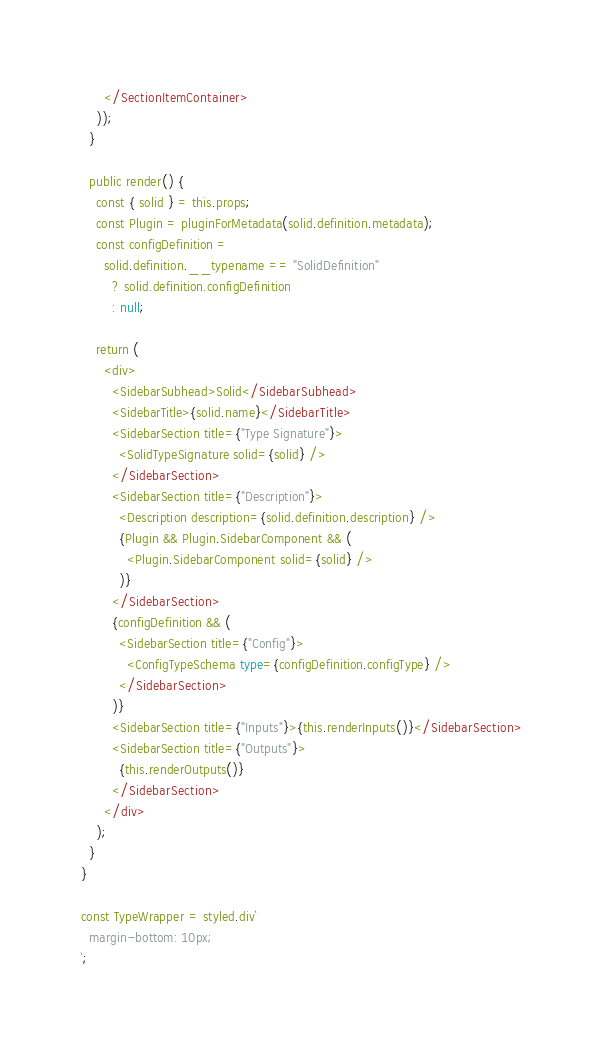Convert code to text. <code><loc_0><loc_0><loc_500><loc_500><_TypeScript_>      </SectionItemContainer>
    ));
  }

  public render() {
    const { solid } = this.props;
    const Plugin = pluginForMetadata(solid.definition.metadata);
    const configDefinition =
      solid.definition.__typename == "SolidDefinition"
        ? solid.definition.configDefinition
        : null;

    return (
      <div>
        <SidebarSubhead>Solid</SidebarSubhead>
        <SidebarTitle>{solid.name}</SidebarTitle>
        <SidebarSection title={"Type Signature"}>
          <SolidTypeSignature solid={solid} />
        </SidebarSection>
        <SidebarSection title={"Description"}>
          <Description description={solid.definition.description} />
          {Plugin && Plugin.SidebarComponent && (
            <Plugin.SidebarComponent solid={solid} />
          )}
        </SidebarSection>
        {configDefinition && (
          <SidebarSection title={"Config"}>
            <ConfigTypeSchema type={configDefinition.configType} />
          </SidebarSection>
        )}
        <SidebarSection title={"Inputs"}>{this.renderInputs()}</SidebarSection>
        <SidebarSection title={"Outputs"}>
          {this.renderOutputs()}
        </SidebarSection>
      </div>
    );
  }
}

const TypeWrapper = styled.div`
  margin-bottom: 10px;
`;
</code> 